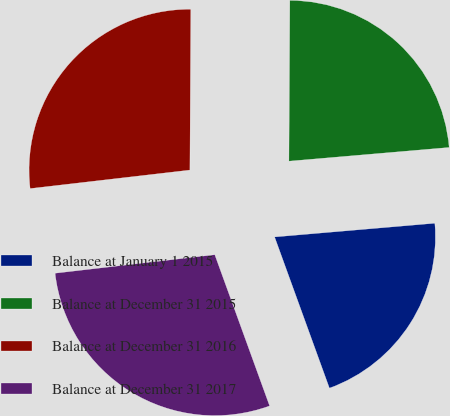Convert chart to OTSL. <chart><loc_0><loc_0><loc_500><loc_500><pie_chart><fcel>Balance at January 1 2015<fcel>Balance at December 31 2015<fcel>Balance at December 31 2016<fcel>Balance at December 31 2017<nl><fcel>20.82%<fcel>23.55%<fcel>26.92%<fcel>28.7%<nl></chart> 